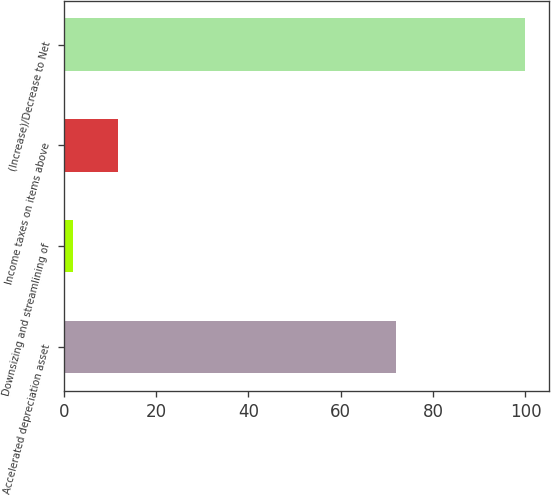Convert chart. <chart><loc_0><loc_0><loc_500><loc_500><bar_chart><fcel>Accelerated depreciation asset<fcel>Downsizing and streamlining of<fcel>Income taxes on items above<fcel>(Increase)/Decrease to Net<nl><fcel>72<fcel>2<fcel>11.8<fcel>100<nl></chart> 